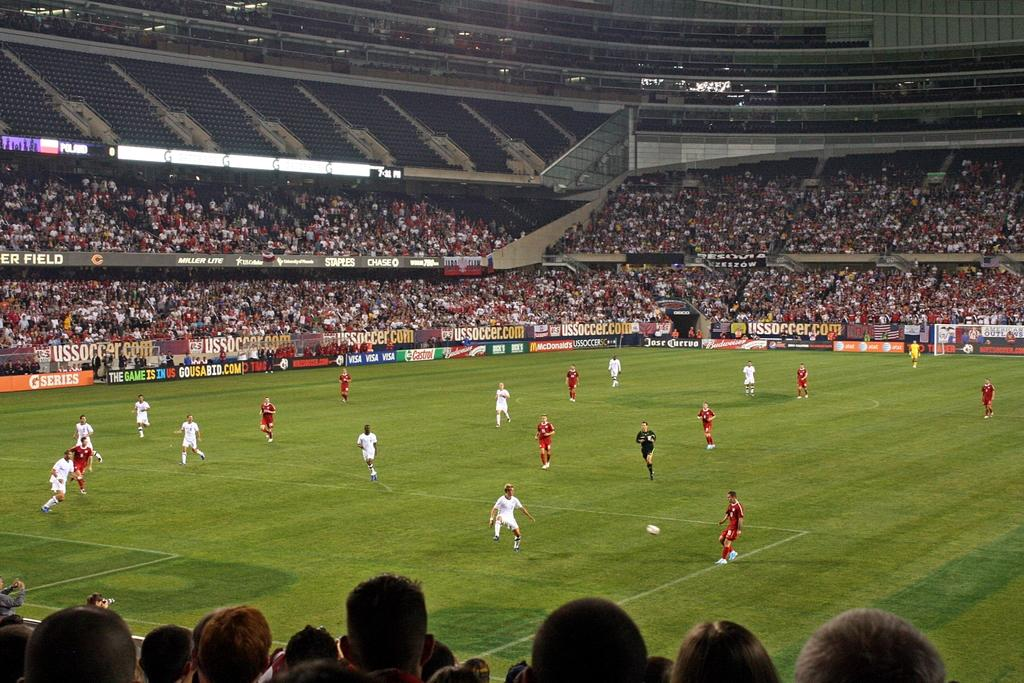<image>
Share a concise interpretation of the image provided. a soccer game with a usa advertisement on the left 